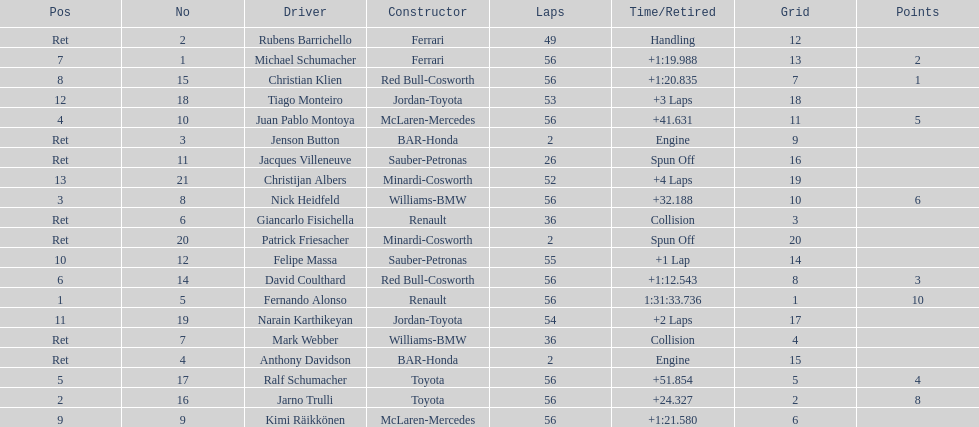Write the full table. {'header': ['Pos', 'No', 'Driver', 'Constructor', 'Laps', 'Time/Retired', 'Grid', 'Points'], 'rows': [['Ret', '2', 'Rubens Barrichello', 'Ferrari', '49', 'Handling', '12', ''], ['7', '1', 'Michael Schumacher', 'Ferrari', '56', '+1:19.988', '13', '2'], ['8', '15', 'Christian Klien', 'Red Bull-Cosworth', '56', '+1:20.835', '7', '1'], ['12', '18', 'Tiago Monteiro', 'Jordan-Toyota', '53', '+3 Laps', '18', ''], ['4', '10', 'Juan Pablo Montoya', 'McLaren-Mercedes', '56', '+41.631', '11', '5'], ['Ret', '3', 'Jenson Button', 'BAR-Honda', '2', 'Engine', '9', ''], ['Ret', '11', 'Jacques Villeneuve', 'Sauber-Petronas', '26', 'Spun Off', '16', ''], ['13', '21', 'Christijan Albers', 'Minardi-Cosworth', '52', '+4 Laps', '19', ''], ['3', '8', 'Nick Heidfeld', 'Williams-BMW', '56', '+32.188', '10', '6'], ['Ret', '6', 'Giancarlo Fisichella', 'Renault', '36', 'Collision', '3', ''], ['Ret', '20', 'Patrick Friesacher', 'Minardi-Cosworth', '2', 'Spun Off', '20', ''], ['10', '12', 'Felipe Massa', 'Sauber-Petronas', '55', '+1 Lap', '14', ''], ['6', '14', 'David Coulthard', 'Red Bull-Cosworth', '56', '+1:12.543', '8', '3'], ['1', '5', 'Fernando Alonso', 'Renault', '56', '1:31:33.736', '1', '10'], ['11', '19', 'Narain Karthikeyan', 'Jordan-Toyota', '54', '+2 Laps', '17', ''], ['Ret', '7', 'Mark Webber', 'Williams-BMW', '36', 'Collision', '4', ''], ['Ret', '4', 'Anthony Davidson', 'BAR-Honda', '2', 'Engine', '15', ''], ['5', '17', 'Ralf Schumacher', 'Toyota', '56', '+51.854', '5', '4'], ['2', '16', 'Jarno Trulli', 'Toyota', '56', '+24.327', '2', '8'], ['9', '9', 'Kimi Räikkönen', 'McLaren-Mercedes', '56', '+1:21.580', '6', '']]} Who was the last driver to actually finish the race? Christijan Albers. 